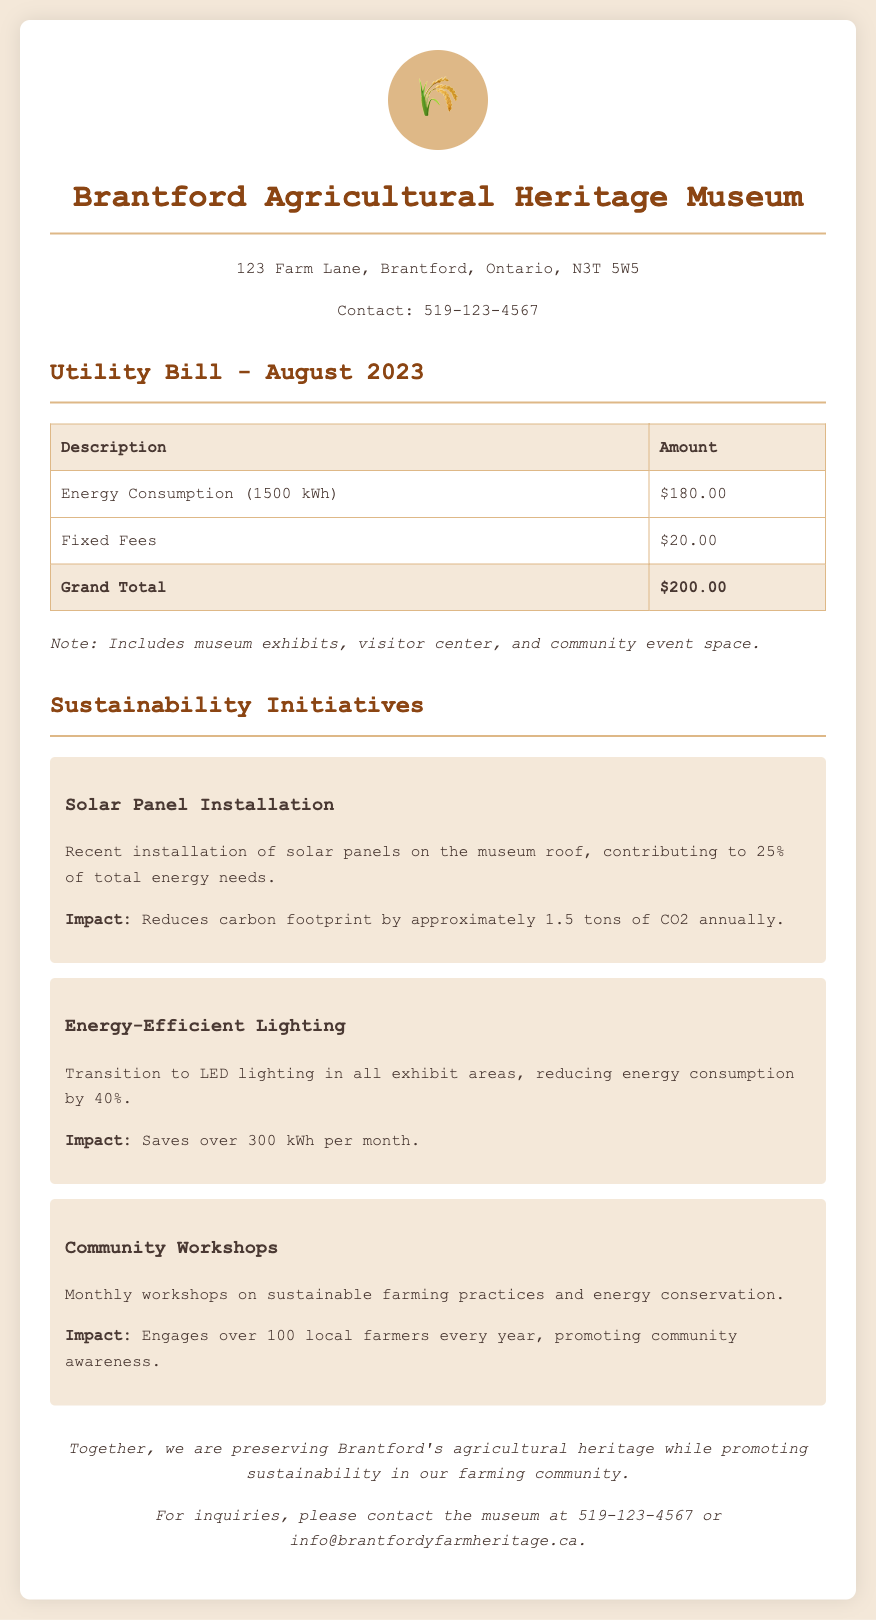What was the energy consumption for August 2023? The energy consumption for August 2023 is listed as 1500 kWh in the utility bill.
Answer: 1500 kWh What is the total amount due on the utility bill? The total amount due is presented as the Grand Total in the utility bill, which is $200.00.
Answer: $200.00 How much does the museum save per month from energy-efficient lighting? The document states that the transition to LED lighting saves over 300 kWh per month.
Answer: 300 kWh What percentage of total energy needs is met by the solar panels? The solar panel installation contributes to 25% of the total energy needs as per the initiatives mentioned.
Answer: 25% How many local farmers engage with the community workshops annually? The document indicates that over 100 local farmers engage with the workshops every year.
Answer: 100 What is the impact of the solar panel installation? The text mentions that the solar panels reduce the carbon footprint by approximately 1.5 tons of CO2 annually.
Answer: 1.5 tons of CO2 What is the address of the Brantford Agricultural Heritage Museum? The address is provided at the top of the document as 123 Farm Lane, Brantford, Ontario, N3T 5W5.
Answer: 123 Farm Lane, Brantford, Ontario, N3T 5W5 What type of lighting was transitioned to in all exhibit areas? The document specifies that the museum transitioned to LED lighting in the exhibit areas.
Answer: LED lighting 